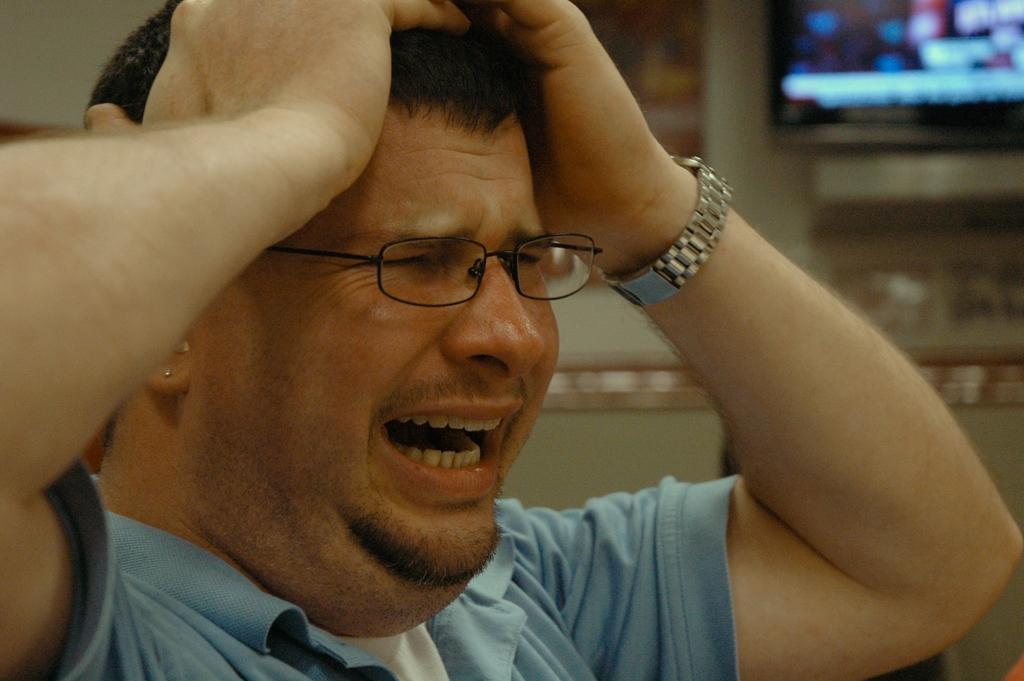What is the main subject of the image? There is a person in the image. What is the person wearing? The person is wearing a blue t-shirt. What is the emotional state of the person? The person is crying. What can be seen on the wall in the image? There is a screen and a frame on the wall in the image. What type of tree can be seen growing through the screen in the image? There is no tree present in the image, and the screen is not being obstructed by any object. 